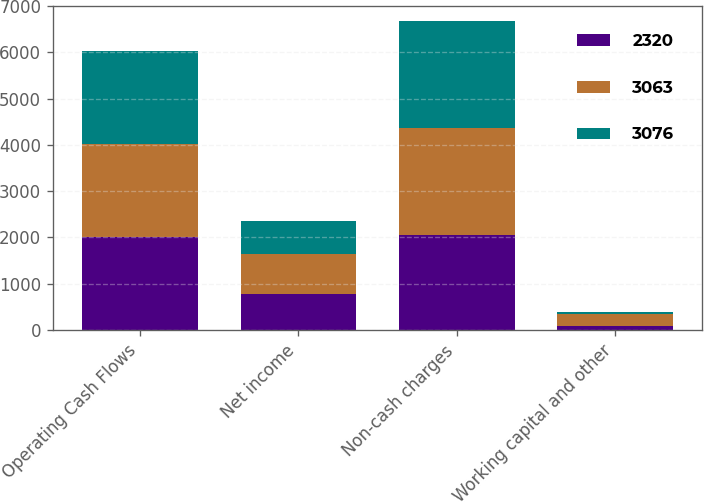Convert chart to OTSL. <chart><loc_0><loc_0><loc_500><loc_500><stacked_bar_chart><ecel><fcel>Operating Cash Flows<fcel>Net income<fcel>Non-cash charges<fcel>Working capital and other<nl><fcel>2320<fcel>2012<fcel>771<fcel>2063<fcel>86<nl><fcel>3063<fcel>2011<fcel>869<fcel>2310<fcel>256<nl><fcel>3076<fcel>2010<fcel>718<fcel>2305<fcel>53<nl></chart> 